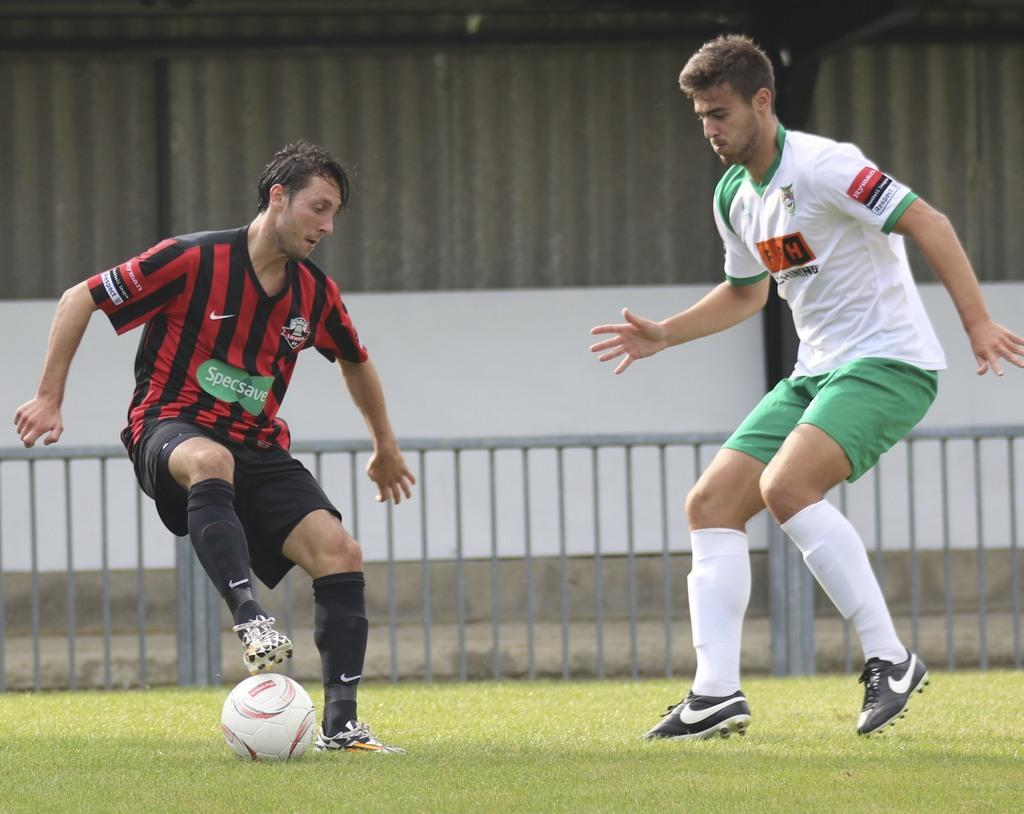How many football players are in the image? There are two football players in the image. What are the football players doing in the image? The football players are playing a football. What type of lipstick is the football player wearing in the image? There is no lipstick or any indication of makeup in the image, as it features two football players playing football. 